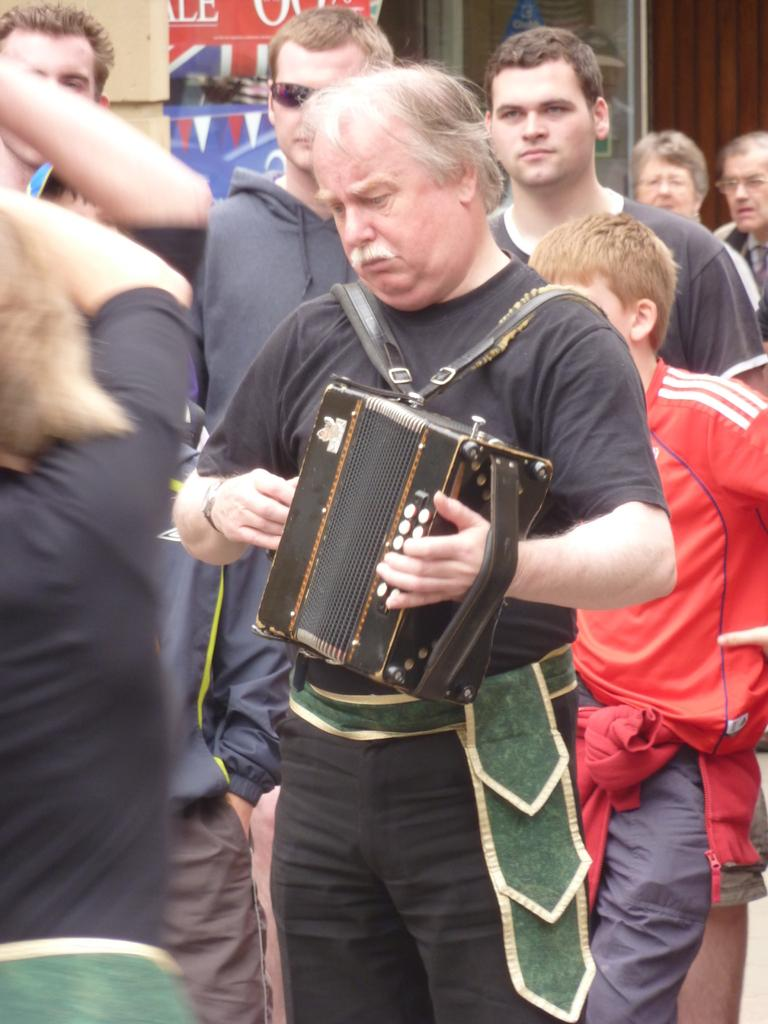How many people are in the image? There is a group of people in the image, but the exact number is not specified. What is one person in the group doing? One person is holding a musical instrument. What can be seen in the background of the image? There is a poster and some objects visible in the background of the image. What type of mint is growing on the property in the image? There is no mention of mint or property in the image; it features a group of people and a background with a poster and objects. 